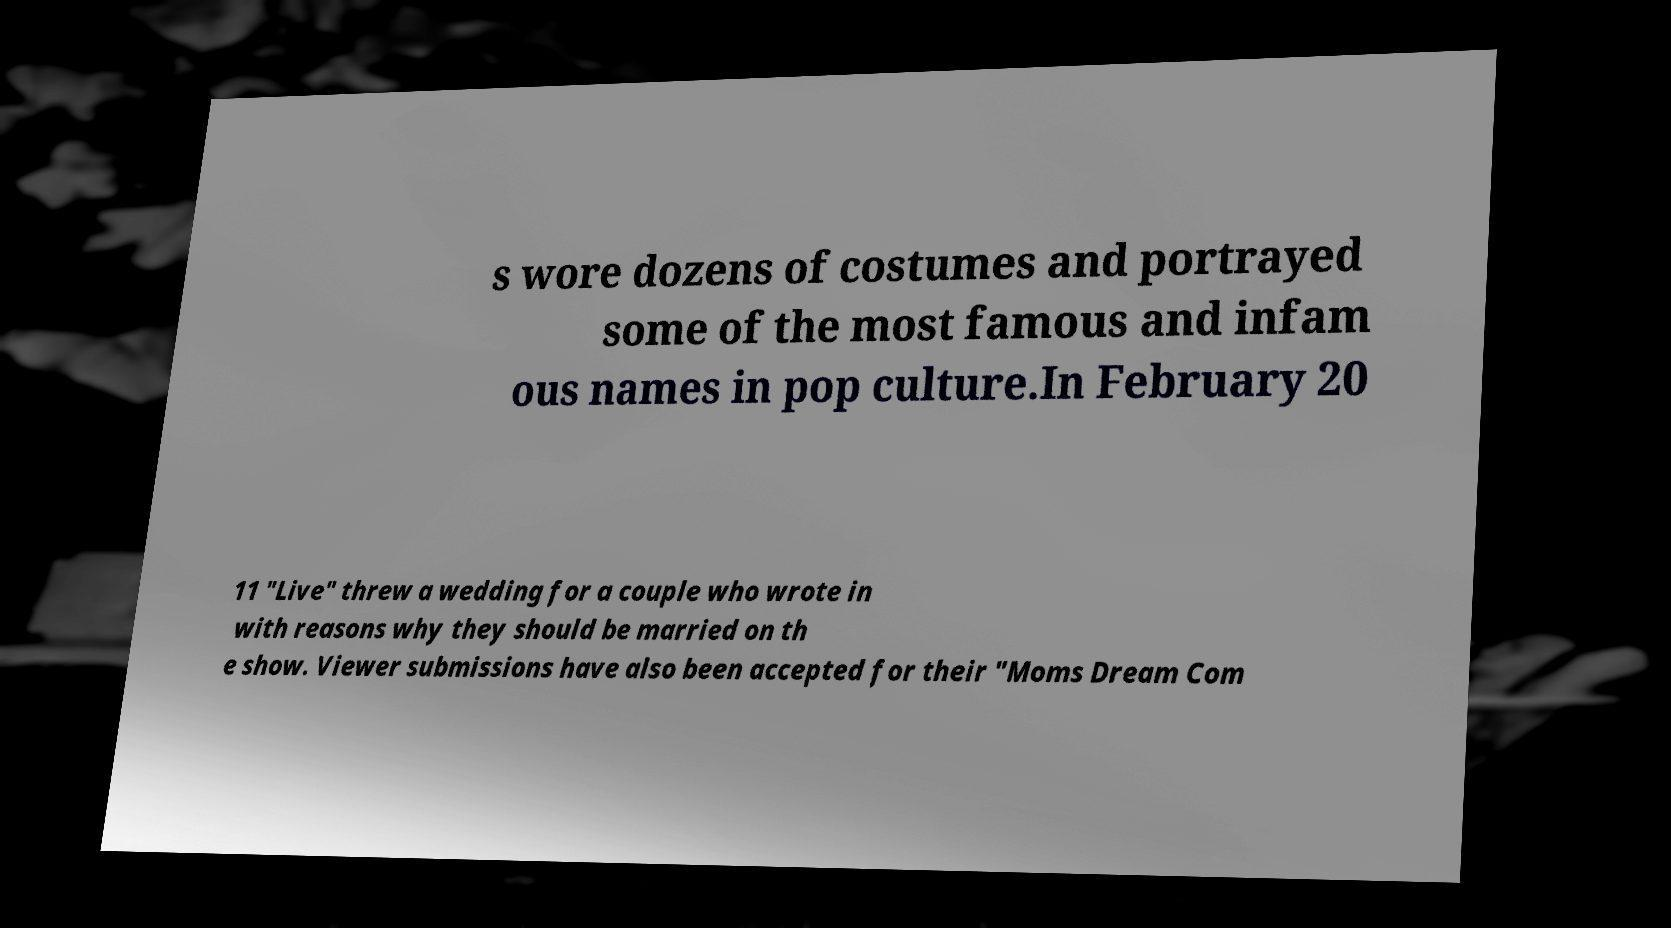Can you accurately transcribe the text from the provided image for me? s wore dozens of costumes and portrayed some of the most famous and infam ous names in pop culture.In February 20 11 "Live" threw a wedding for a couple who wrote in with reasons why they should be married on th e show. Viewer submissions have also been accepted for their "Moms Dream Com 